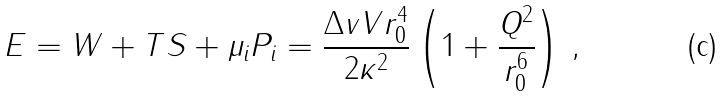<formula> <loc_0><loc_0><loc_500><loc_500>E = W + T S + \mu _ { i } P _ { i } = \frac { \Delta v V r _ { 0 } ^ { 4 } } { 2 \kappa ^ { 2 } } \left ( 1 + \frac { Q ^ { 2 } } { r _ { 0 } ^ { 6 } } \right ) \, ,</formula> 